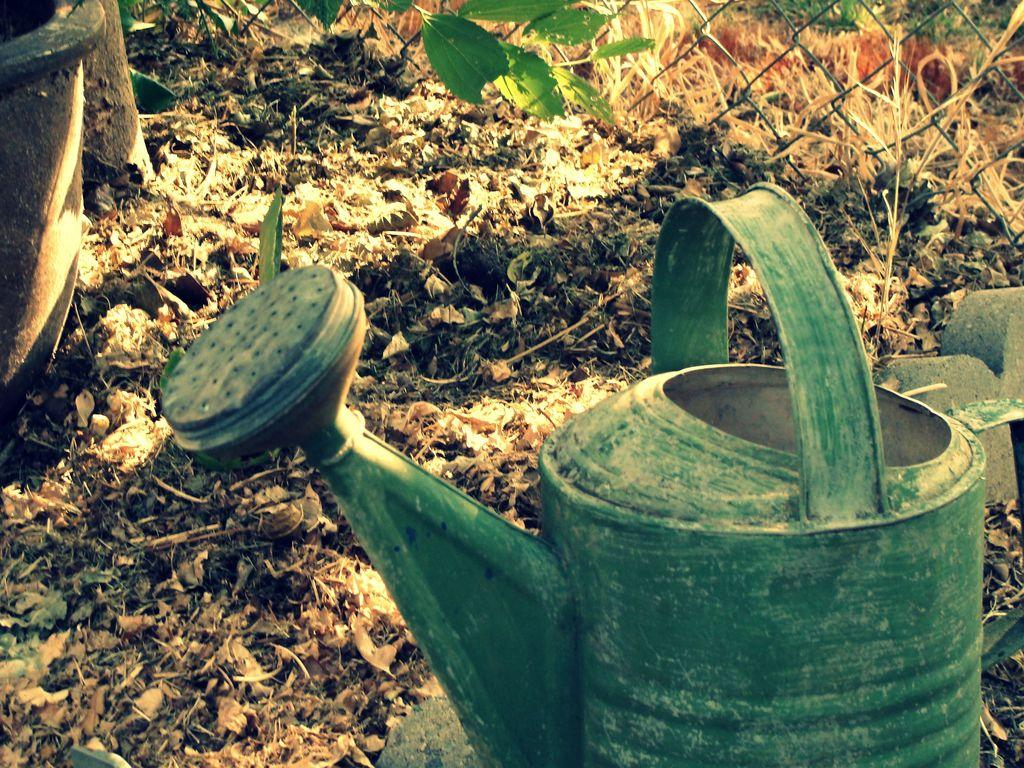What type of natural elements can be seen in the image? There are stones and leaves in the image. What type of structure is present in the image? There is a fence in the image. What object is used for watering plants in the image? There is a water can in the image. How many robins are sitting on the fence in the image? There are no robins present in the image; only stones, leaves, a fence, and a water can are visible. What type of clouds can be seen in the image? There are no clouds visible in the image. 